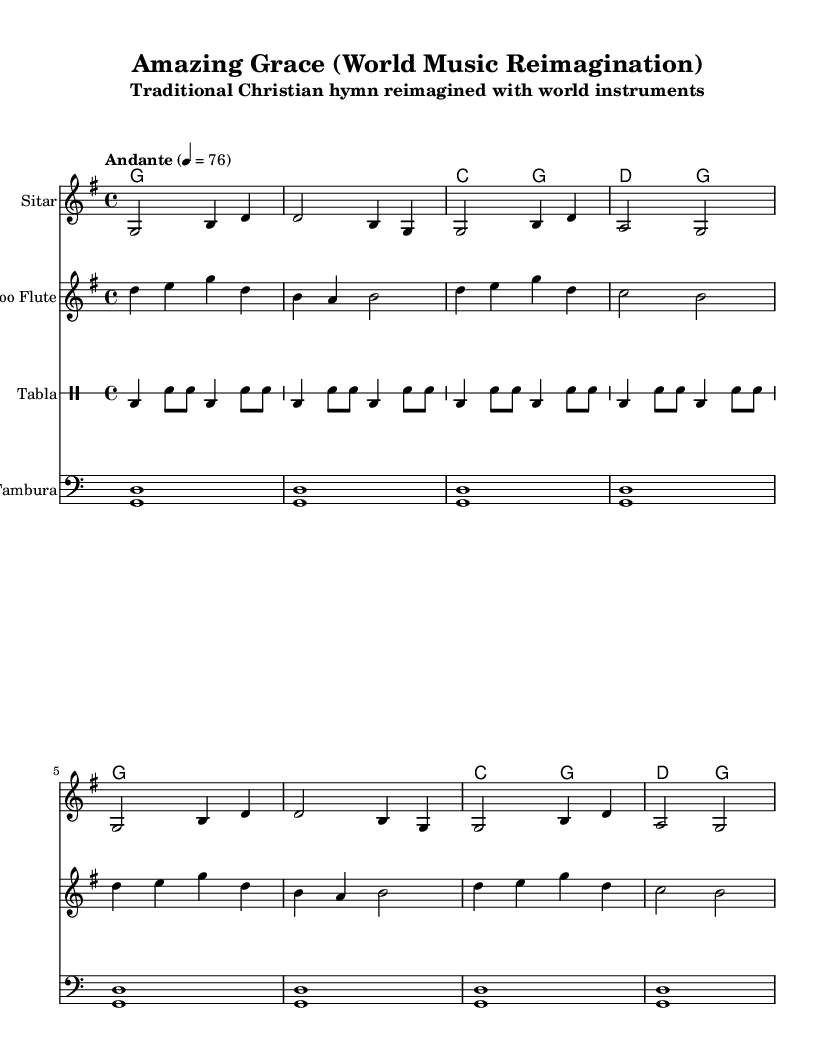What is the key signature of this music? The key signature is G major, which has one sharp (F#). This is indicated at the beginning of the staff.
Answer: G major What is the time signature of the piece? The time signature is 4/4, meaning there are four beats in each measure. This is clearly marked at the beginning of the score.
Answer: 4/4 What is the tempo marking given for this piece? The tempo marking provided is "Andante," which indicates a moderate pace. The metronome marking is also indicated as 76 beats per minute.
Answer: Andante Which instrument plays the main melody? The Sitar is marked as the instrument playing the main melody, as indicated by the instrument name at the top of its staff.
Answer: Sitar How many measures are in the given melody? The melody consists of 8 measures, as it spans from the beginning to the end of the provided musical lines. Each line corresponds to two measures.
Answer: 8 What is the rhythmic pattern of the Tabla in the score? The rhythmic pattern for the Tabla is indicated by the notation, where there are repeated sections of bass and snare hits in a specific pattern, described by the given drummode.
Answer: bass-drum-snare What makes this arrangement fit into the World Music category? This arrangement consists of traditional hymn material reinterpreted with diverse world instruments like the Sitar and Tabla, showcasing a blend of cultural styles.
Answer: Diverse instruments 